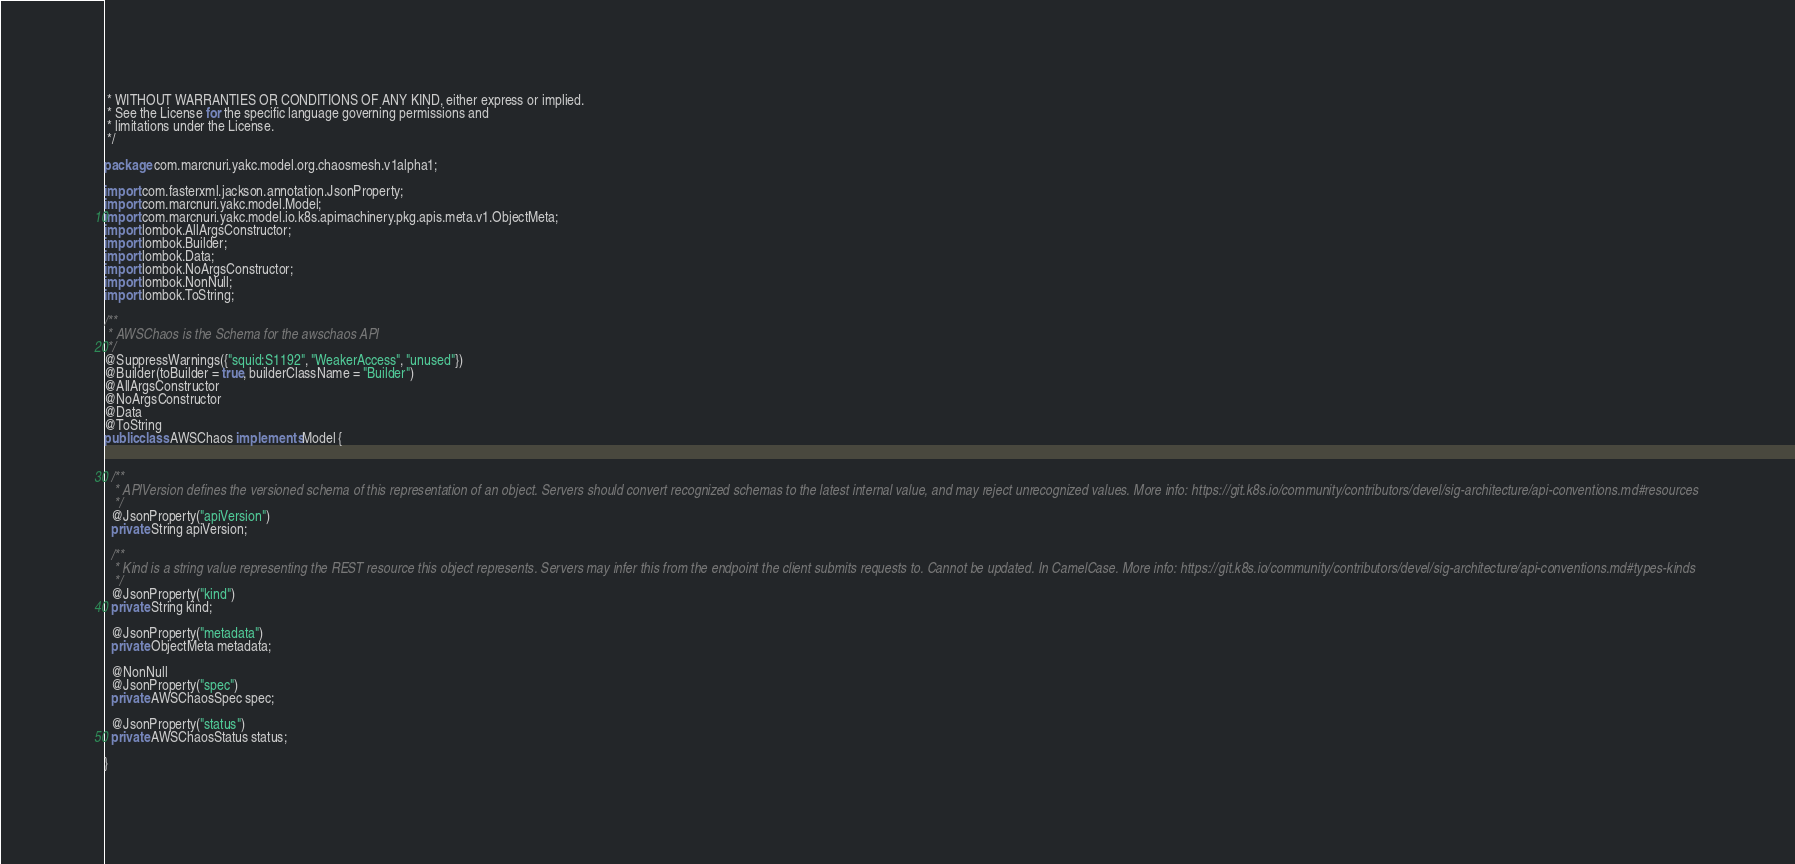<code> <loc_0><loc_0><loc_500><loc_500><_Java_> * WITHOUT WARRANTIES OR CONDITIONS OF ANY KIND, either express or implied.
 * See the License for the specific language governing permissions and
 * limitations under the License.
 */

package com.marcnuri.yakc.model.org.chaosmesh.v1alpha1;

import com.fasterxml.jackson.annotation.JsonProperty;
import com.marcnuri.yakc.model.Model;
import com.marcnuri.yakc.model.io.k8s.apimachinery.pkg.apis.meta.v1.ObjectMeta;
import lombok.AllArgsConstructor;
import lombok.Builder;
import lombok.Data;
import lombok.NoArgsConstructor;
import lombok.NonNull;
import lombok.ToString;

/**
 * AWSChaos is the Schema for the awschaos API
 */
@SuppressWarnings({"squid:S1192", "WeakerAccess", "unused"})
@Builder(toBuilder = true, builderClassName = "Builder")
@AllArgsConstructor
@NoArgsConstructor
@Data
@ToString
public class AWSChaos implements Model {


  /**
   * APIVersion defines the versioned schema of this representation of an object. Servers should convert recognized schemas to the latest internal value, and may reject unrecognized values. More info: https://git.k8s.io/community/contributors/devel/sig-architecture/api-conventions.md#resources
   */
  @JsonProperty("apiVersion")
  private String apiVersion;

  /**
   * Kind is a string value representing the REST resource this object represents. Servers may infer this from the endpoint the client submits requests to. Cannot be updated. In CamelCase. More info: https://git.k8s.io/community/contributors/devel/sig-architecture/api-conventions.md#types-kinds
   */
  @JsonProperty("kind")
  private String kind;

  @JsonProperty("metadata")
  private ObjectMeta metadata;

  @NonNull
  @JsonProperty("spec")
  private AWSChaosSpec spec;

  @JsonProperty("status")
  private AWSChaosStatus status;

}

</code> 